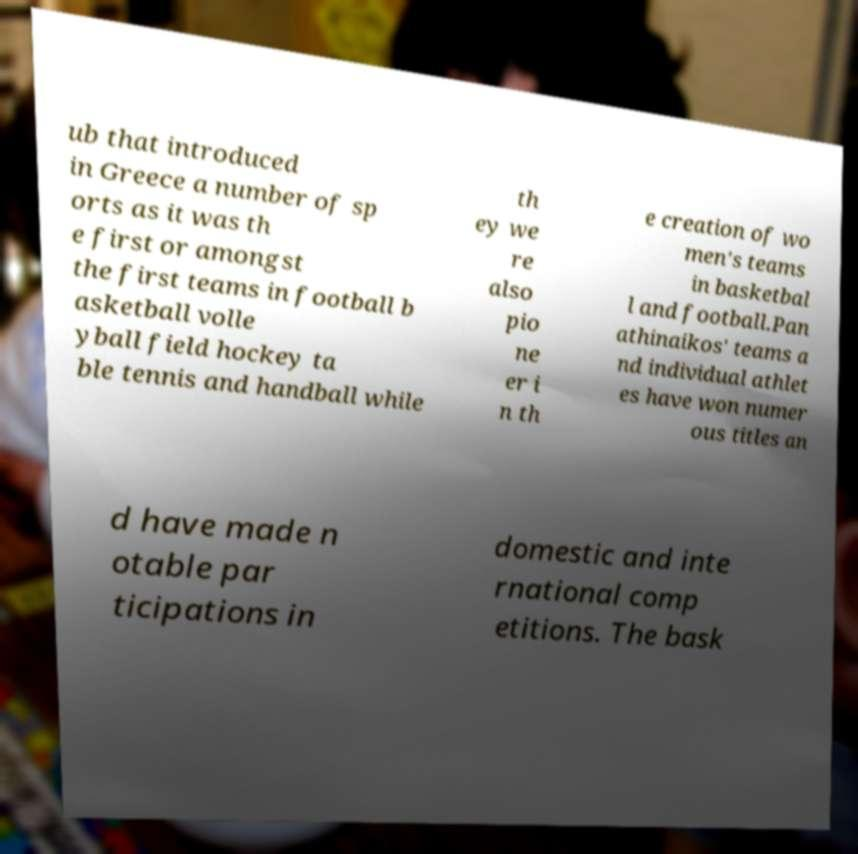What messages or text are displayed in this image? I need them in a readable, typed format. ub that introduced in Greece a number of sp orts as it was th e first or amongst the first teams in football b asketball volle yball field hockey ta ble tennis and handball while th ey we re also pio ne er i n th e creation of wo men's teams in basketbal l and football.Pan athinaikos' teams a nd individual athlet es have won numer ous titles an d have made n otable par ticipations in domestic and inte rnational comp etitions. The bask 